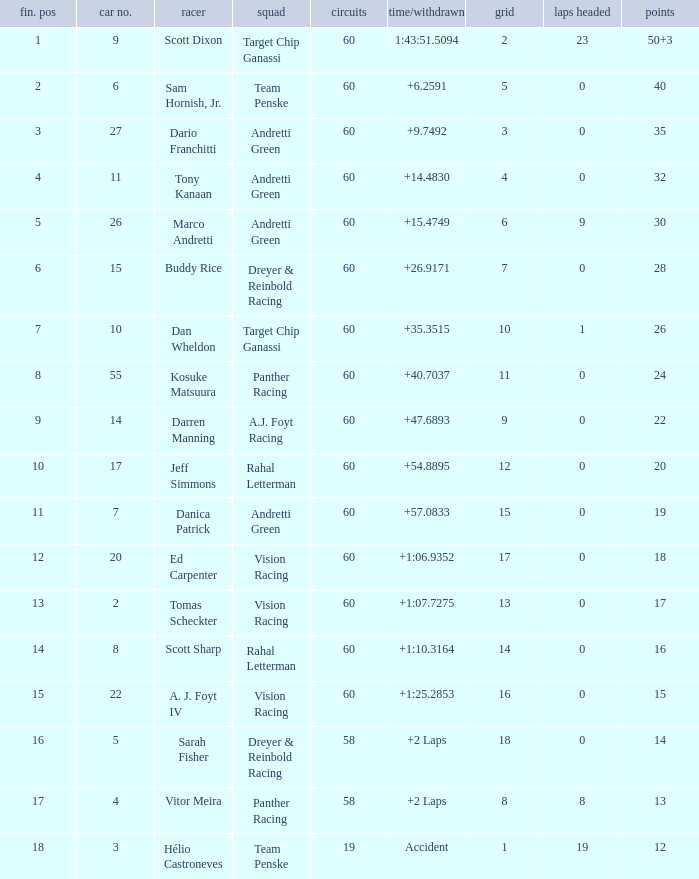Name the drive for points being 13 Vitor Meira. 